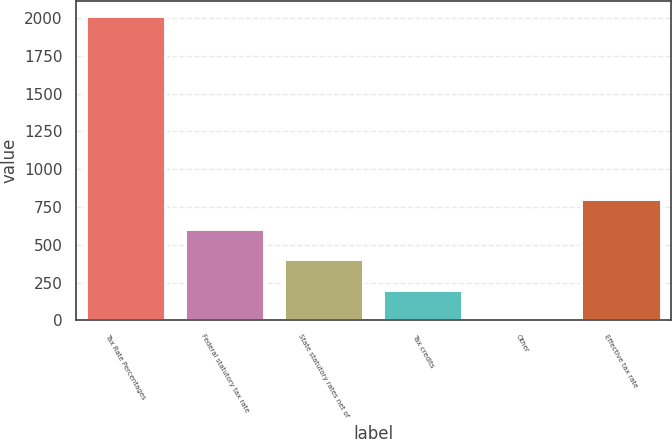Convert chart to OTSL. <chart><loc_0><loc_0><loc_500><loc_500><bar_chart><fcel>Tax Rate Percentages<fcel>Federal statutory tax rate<fcel>State statutory rates net of<fcel>Tax credits<fcel>Other<fcel>Effective tax rate<nl><fcel>2014<fcel>604.34<fcel>402.96<fcel>201.58<fcel>0.2<fcel>805.72<nl></chart> 